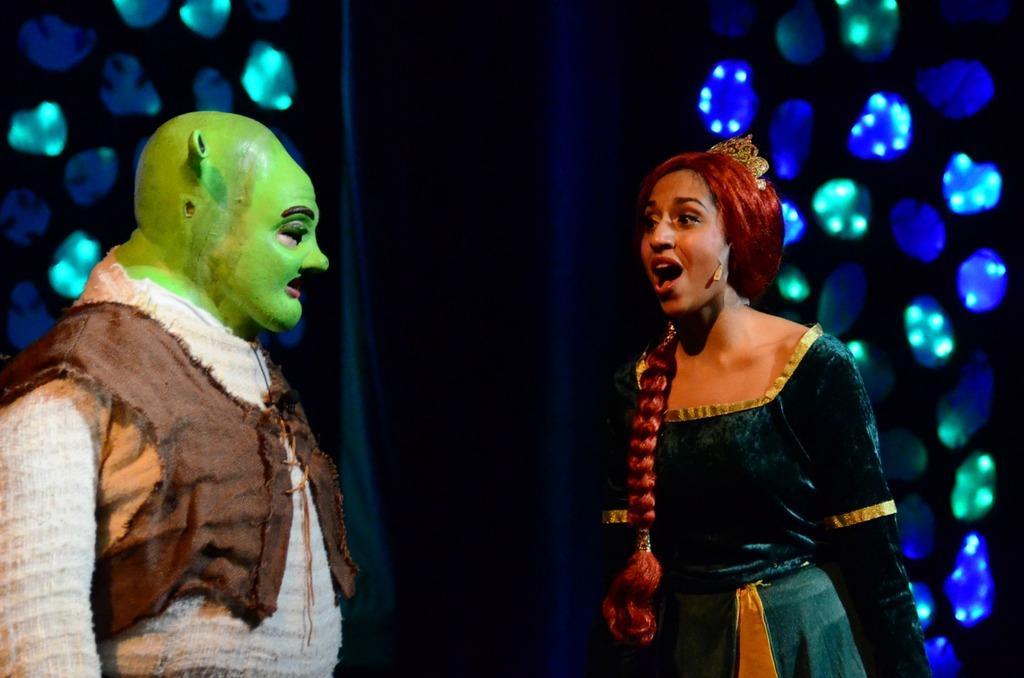In one or two sentences, can you explain what this image depicts? In this picture we can see there are two people in the fancy dresses. Behind the people there is the dark background and lights. 